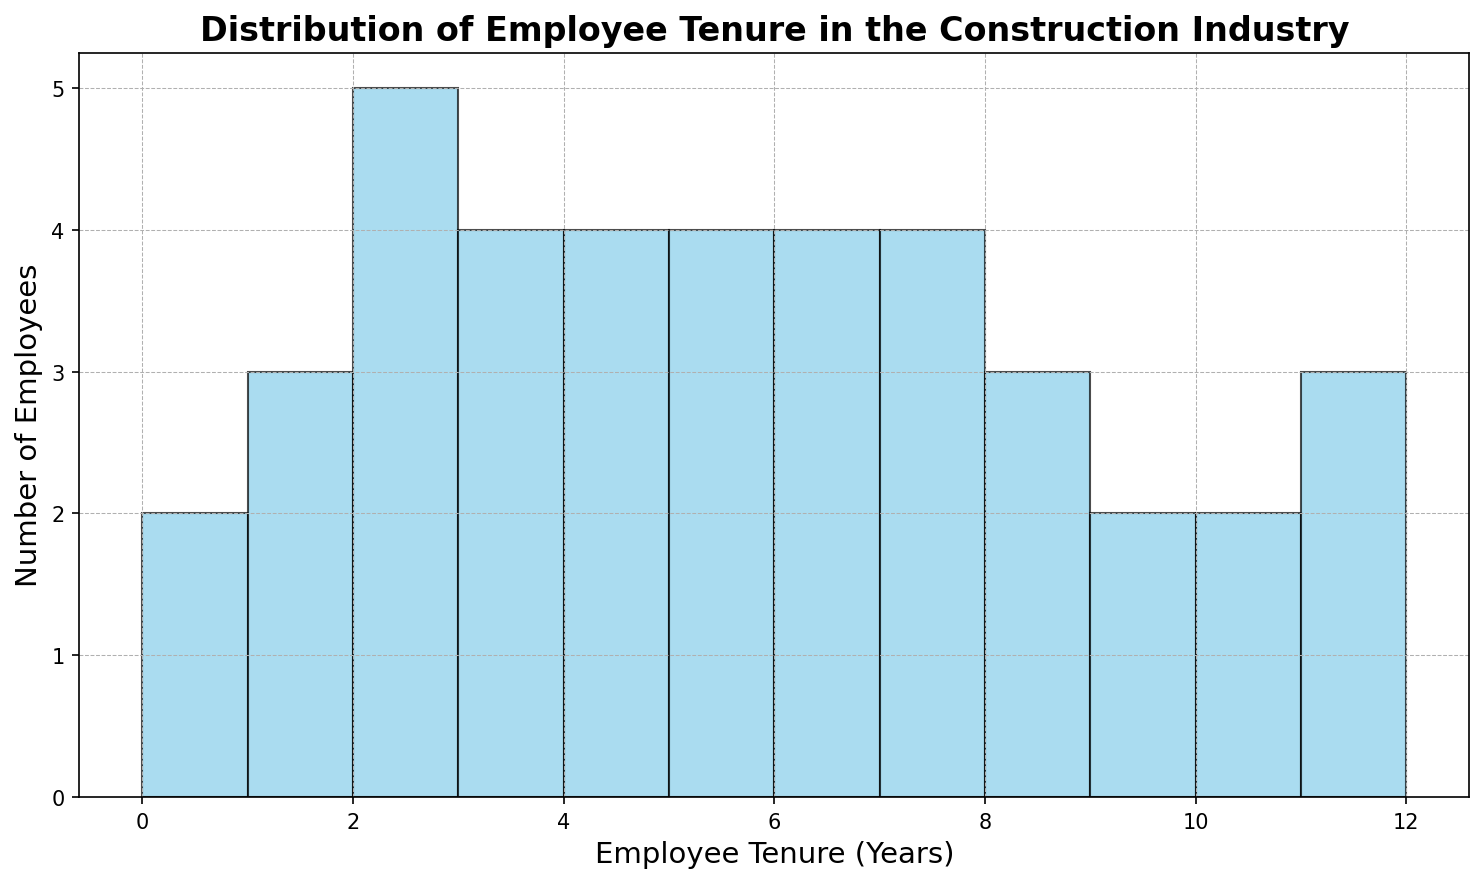What is the most common employee tenure? The mode, or most common value, can be observed by identifying the bar that is the tallest in the histogram. This represents the tenure with the highest number of employees.
Answer: 3 years Which bins have the same frequency of employees as the bin with 5 years of tenure? First, count the number of employees in the bin with 5 years of tenure by checking the height of the bar. Next, compare this count with the counts of other bins to find matches.
Answer: 4 years, 6 years How many employees have between 2 and 4 years of tenure? Add the number of employees in the bins for 2 years, 3 years, and 4 years. This can be determined by summing the heights of these three bars.
Answer: 9 employees What is the total number of employees with 6 years or more of tenure? Sum the heights of all bars representing 6 years of tenure and higher. This involves adding the bars for 6, 7, 8, 9, 10, 11, and 12 years.
Answer: 16 employees Which tenure has a higher frequency, 1 year or 7 years? Compare the heights of the bars for 1 year and 7 years of tenure to see which is taller.
Answer: 7 years How does the frequency of employees with less than 3 years of tenure compare to those with more than 10 years? Sum the heights of bars representing less than 3 years of tenure (0.5, 1, 2 years) and compare this total with the sum of heights for bars representing more than 10 years (11, 12 years).
Answer: Less than 3 years has a higher frequency What is the difference in the number of employees between the most frequent tenure bin and the least frequent tenure bin? Identify the bins with the highest and lowest frequencies by looking at their bar heights. Then, subtract the number of employees in the least frequent bin from the number in the most frequent bin.
Answer: 4 employees Is there a significant number of employees with a tenure of half a year? Check the height of the bar for 0.5 years of tenure and compare it against others to judge if it is significant (relatively high).
Answer: No Which tenure categories have exactly four employees? Identify the bars with a height of 4 employees to find which tenure years these represent.
Answer: 2 years, 4 years How many more employees have a tenure of 8 years compared to a tenure of 1 year? Count the number of employees in the 8-year tenure bin and subtract the count in the 1-year tenure bin to find the difference.
Answer: 2 employees 